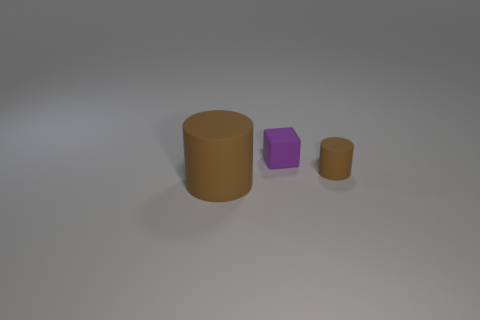Subtract all cylinders. How many objects are left? 1 Subtract 2 cylinders. How many cylinders are left? 0 Subtract all red cubes. Subtract all green cylinders. How many cubes are left? 1 Subtract all yellow cylinders. How many yellow blocks are left? 0 Subtract all brown cubes. Subtract all tiny objects. How many objects are left? 1 Add 2 brown rubber cylinders. How many brown rubber cylinders are left? 4 Add 1 tiny green things. How many tiny green things exist? 1 Add 1 large blue objects. How many objects exist? 4 Subtract 0 cyan spheres. How many objects are left? 3 